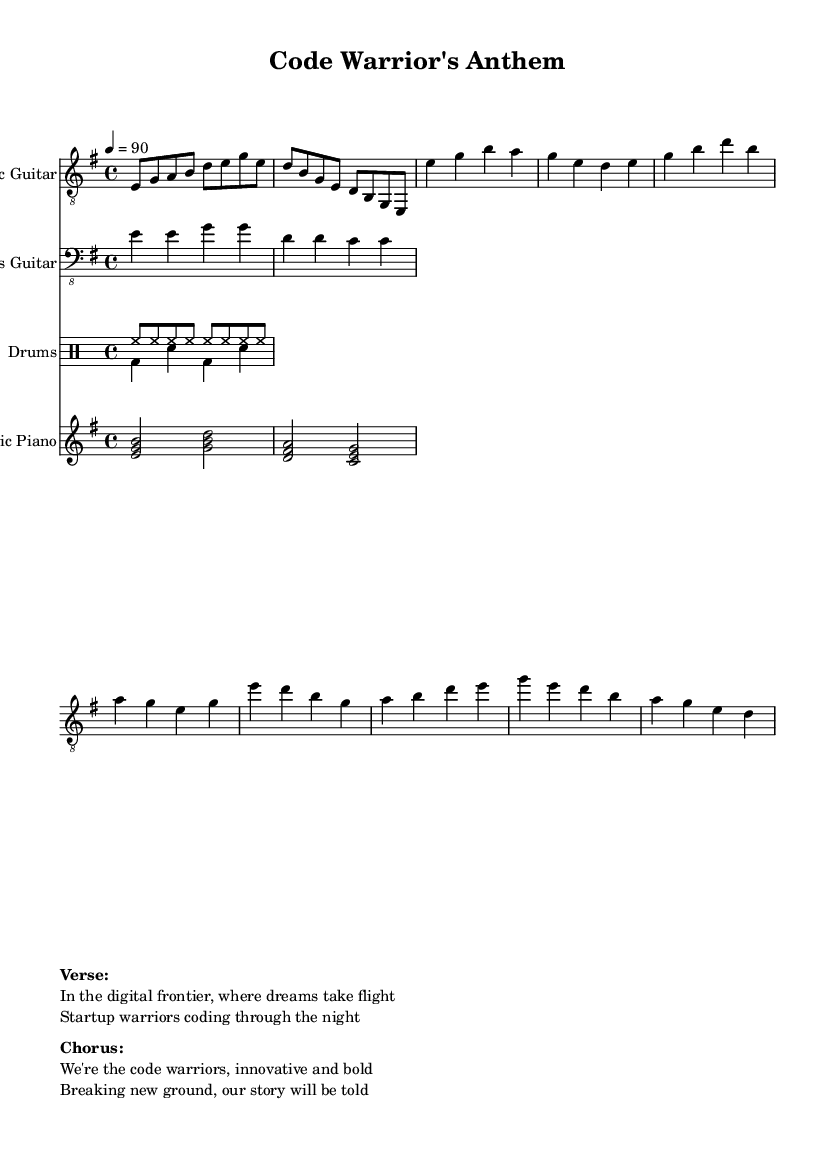What is the key signature of this music? The key signature is E minor, which has one sharp (F#). The key signature is indicated at the beginning of the staff, right after the clef.
Answer: E minor What is the time signature of this music? The time signature is 4/4, which means there are four beats in each measure and the quarter note gets one beat. This is indicated at the beginning of the score in front of the tempo marking.
Answer: 4/4 What is the tempo marking of this music? The tempo marking shows that the piece should be played at a speed of 90 beats per minute, indicated by "4 = 90" at the beginning of the score.
Answer: 90 How many measures are in the verse section? The verse consists of eight measures in total, which can be counted by analyzing the verse segment in the electric guitar staff, where each grouping separated by bar lines indicates a measure.
Answer: 8 What type of instrument is indicated for the main riff? The main riff is indicated for the Electric Guitar, as specified in the instrument name at the beginning of the respective staff.
Answer: Electric Guitar Which section includes the phrase "We're the code warriors, innovative and bold"? This phrase is part of the chorus section, which is indicated following the verse in the markup section of the score.
Answer: Chorus What rhythmic pattern does the drum section primarily use? The drum section primarily uses a basic rock rhythm that includes hi-hat and bass drum patterns, which can be seen in the drummode for both up and down parts. This pattern establishes the driving beat characteristic of Electric Blues.
Answer: Rock rhythm 